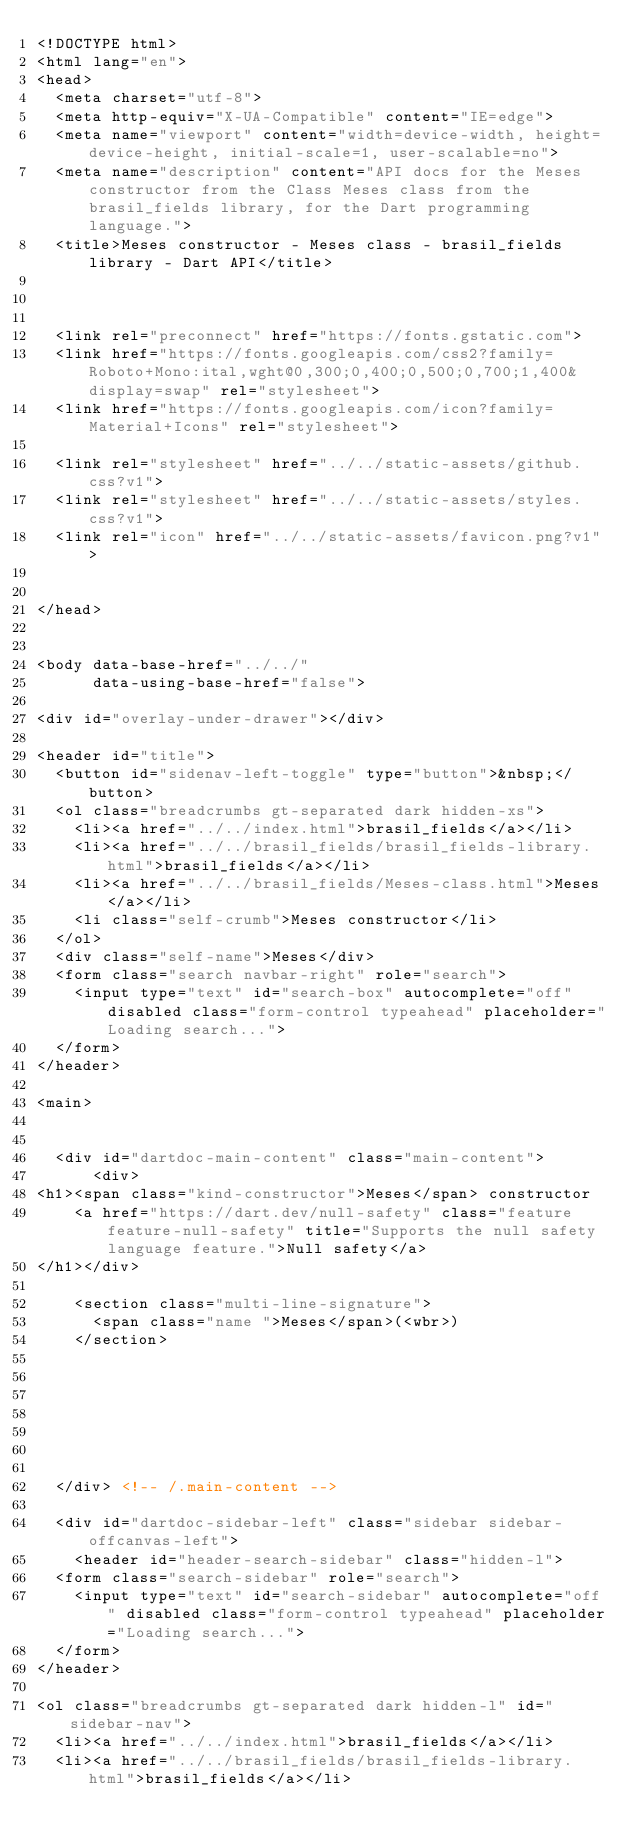<code> <loc_0><loc_0><loc_500><loc_500><_HTML_><!DOCTYPE html>
<html lang="en">
<head>
  <meta charset="utf-8">
  <meta http-equiv="X-UA-Compatible" content="IE=edge">
  <meta name="viewport" content="width=device-width, height=device-height, initial-scale=1, user-scalable=no">
  <meta name="description" content="API docs for the Meses constructor from the Class Meses class from the brasil_fields library, for the Dart programming language.">
  <title>Meses constructor - Meses class - brasil_fields library - Dart API</title>


  
  <link rel="preconnect" href="https://fonts.gstatic.com">
  <link href="https://fonts.googleapis.com/css2?family=Roboto+Mono:ital,wght@0,300;0,400;0,500;0,700;1,400&display=swap" rel="stylesheet">
  <link href="https://fonts.googleapis.com/icon?family=Material+Icons" rel="stylesheet">
  
  <link rel="stylesheet" href="../../static-assets/github.css?v1">
  <link rel="stylesheet" href="../../static-assets/styles.css?v1">
  <link rel="icon" href="../../static-assets/favicon.png?v1">

  
</head>


<body data-base-href="../../"
      data-using-base-href="false">

<div id="overlay-under-drawer"></div>

<header id="title">
  <button id="sidenav-left-toggle" type="button">&nbsp;</button>
  <ol class="breadcrumbs gt-separated dark hidden-xs">
    <li><a href="../../index.html">brasil_fields</a></li>
    <li><a href="../../brasil_fields/brasil_fields-library.html">brasil_fields</a></li>
    <li><a href="../../brasil_fields/Meses-class.html">Meses</a></li>
    <li class="self-crumb">Meses constructor</li>
  </ol>
  <div class="self-name">Meses</div>
  <form class="search navbar-right" role="search">
    <input type="text" id="search-box" autocomplete="off" disabled class="form-control typeahead" placeholder="Loading search...">
  </form>
</header>

<main>


  <div id="dartdoc-main-content" class="main-content">
      <div>
<h1><span class="kind-constructor">Meses</span> constructor 
    <a href="https://dart.dev/null-safety" class="feature feature-null-safety" title="Supports the null safety language feature.">Null safety</a>
</h1></div>

    <section class="multi-line-signature">
      <span class="name ">Meses</span>(<wbr>)
    </section>

    


    


  </div> <!-- /.main-content -->

  <div id="dartdoc-sidebar-left" class="sidebar sidebar-offcanvas-left">
    <header id="header-search-sidebar" class="hidden-l">
  <form class="search-sidebar" role="search">
    <input type="text" id="search-sidebar" autocomplete="off" disabled class="form-control typeahead" placeholder="Loading search...">
  </form>
</header>

<ol class="breadcrumbs gt-separated dark hidden-l" id="sidebar-nav">
  <li><a href="../../index.html">brasil_fields</a></li>
  <li><a href="../../brasil_fields/brasil_fields-library.html">brasil_fields</a></li></code> 